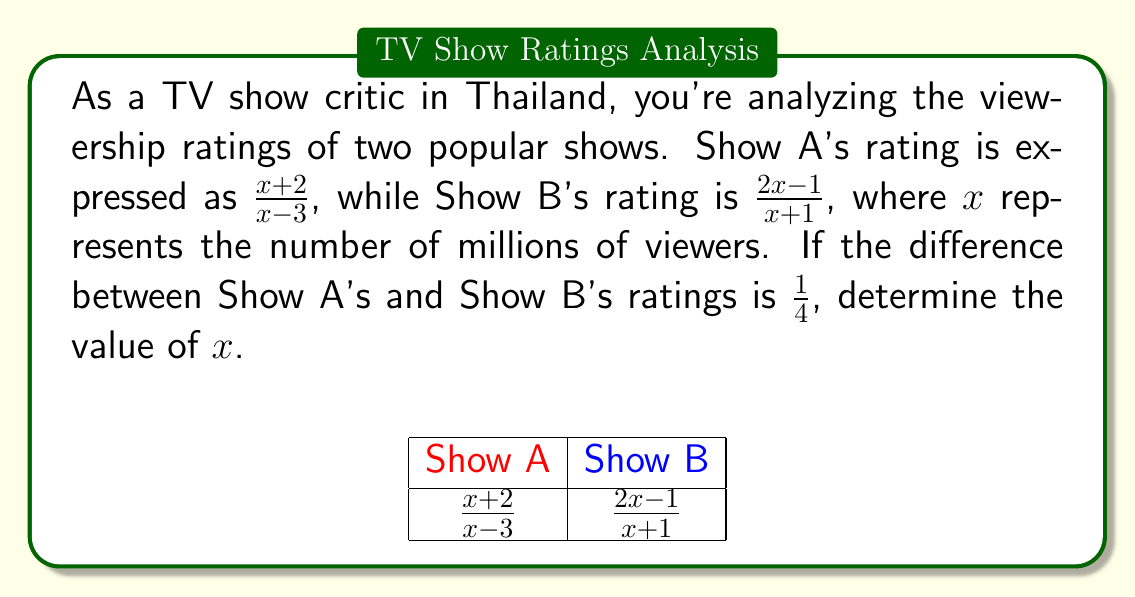What is the answer to this math problem? Let's approach this step-by-step:

1) We're told that the difference between Show A's and Show B's ratings is $\frac{1}{4}$. We can express this as an equation:

   $$\frac{x+2}{x-3} - \frac{2x-1}{x+1} = \frac{1}{4}$$

2) To subtract these fractions, we need a common denominator. The common denominator will be $(x-3)(x+1)$:

   $$\frac{(x+2)(x+1) - (2x-1)(x-3)}{(x-3)(x+1)} = \frac{1}{4}$$

3) Let's expand the numerator:
   $$(x^2+3x+2) - (2x^2-7x+3) = \frac{1}{4}(x-3)(x+1)$$

4) Simplify the left side:
   $$-x^2+10x-1 = \frac{1}{4}(x^2-2x-3)$$

5) Multiply both sides by 4:
   $$-4x^2+40x-4 = x^2-2x-3$$

6) Rearrange all terms to one side:
   $$-5x^2+42x-1 = 0$$

7) This is a quadratic equation. We can solve it using the quadratic formula:
   $$x = \frac{-b \pm \sqrt{b^2-4ac}}{2a}$$
   where $a=-5$, $b=42$, and $c=-1$

8) Plugging in these values:
   $$x = \frac{-42 \pm \sqrt{42^2-4(-5)(-1)}}{2(-5)}$$

9) Simplify:
   $$x = \frac{-42 \pm \sqrt{1764-20}}{-10} = \frac{-42 \pm \sqrt{1744}}{-10}$$

10) Simplify further:
    $$x = \frac{-42 \pm 41.76}{-10}$$

11) This gives us two solutions:
    $$x \approx 8.376 \text{ or } x \approx 0.024$$

12) Since $x$ represents millions of viewers, the only logical solution is $x \approx 8.376$.
Answer: $x \approx 8.376$ million viewers 